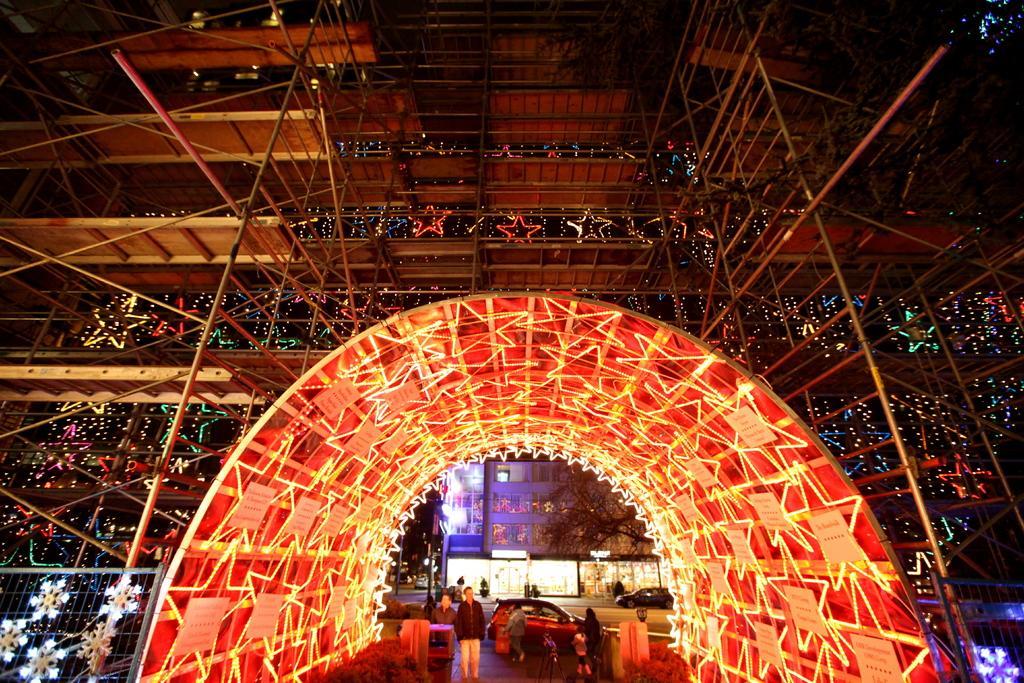Describe this image in one or two sentences. In this image we can see the entrance of the building with lightning. At the bottom we can see some papers with text attached to the arch. At the bottom we can see some people. We can also see the cars on the road. There is also a building and also a tree. 